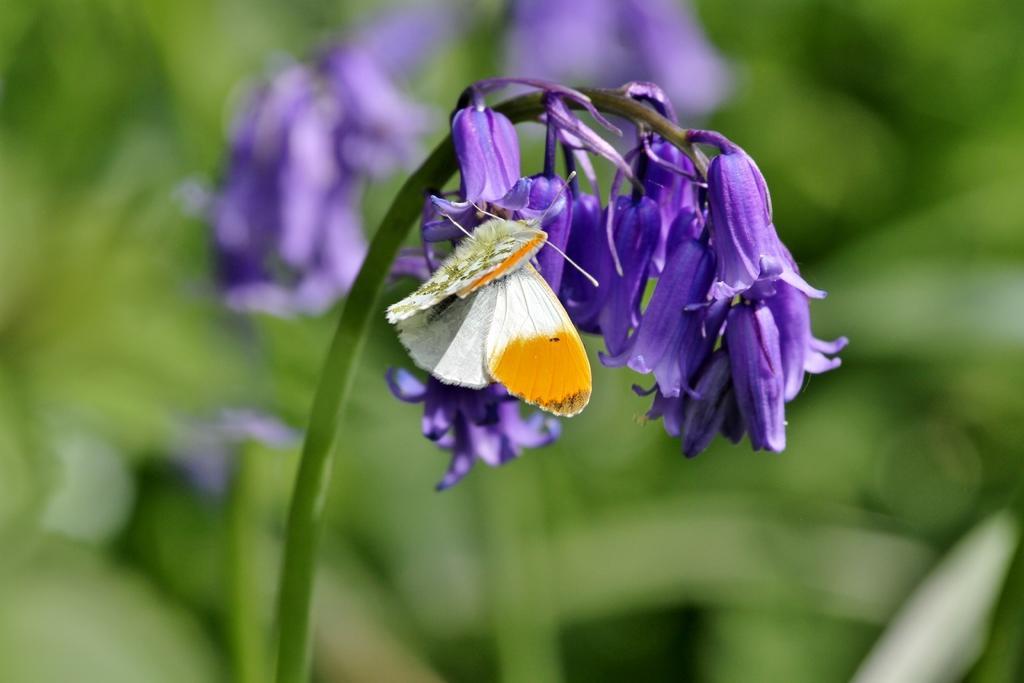Can you describe this image briefly? In this picture there are purple color flowers on the plant and there is a butterfly on the flower. At the back the image is blurry. 